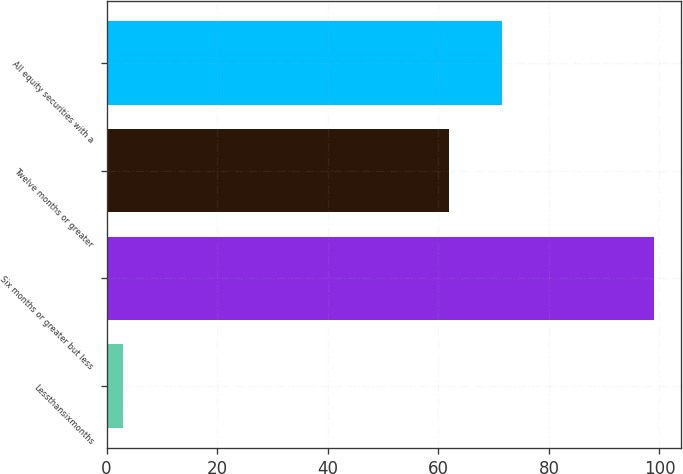Convert chart to OTSL. <chart><loc_0><loc_0><loc_500><loc_500><bar_chart><fcel>Lessthansixmonths<fcel>Six months or greater but less<fcel>Twelve months or greater<fcel>All equity securities with a<nl><fcel>3<fcel>99<fcel>62<fcel>71.6<nl></chart> 